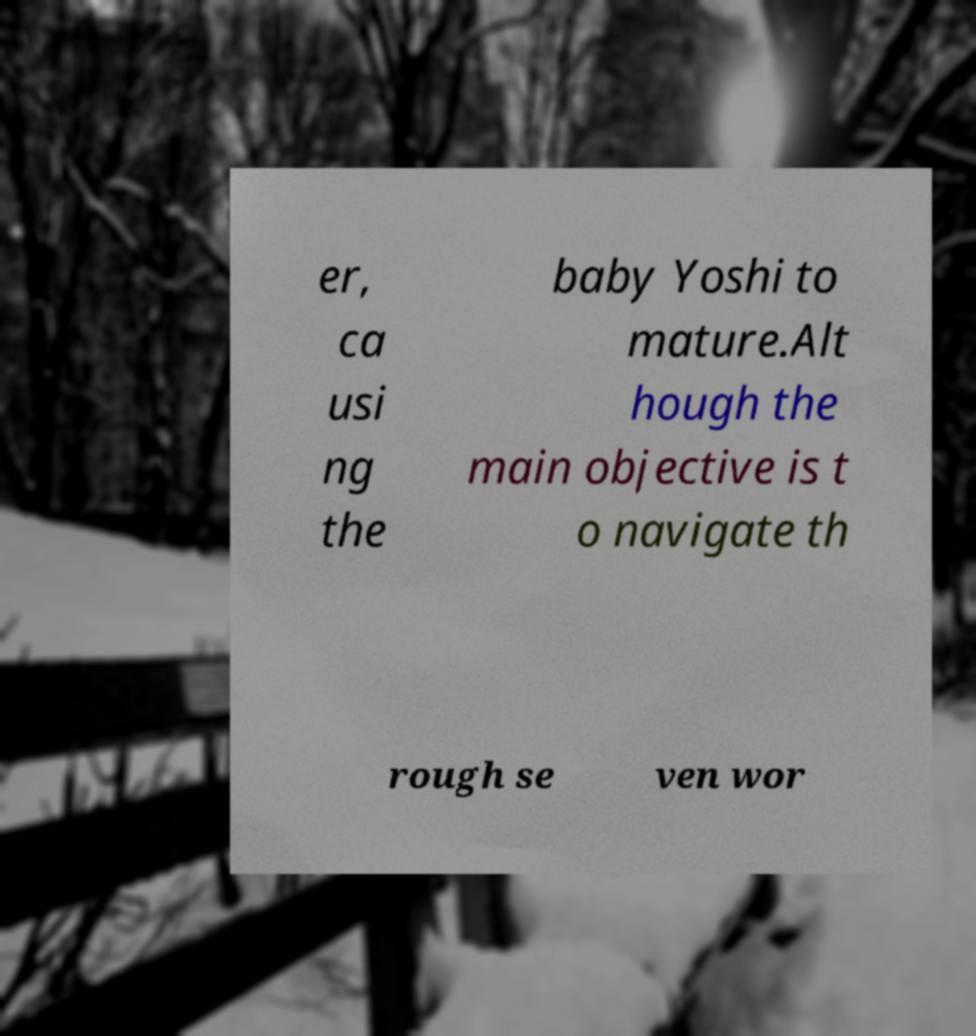Can you accurately transcribe the text from the provided image for me? er, ca usi ng the baby Yoshi to mature.Alt hough the main objective is t o navigate th rough se ven wor 